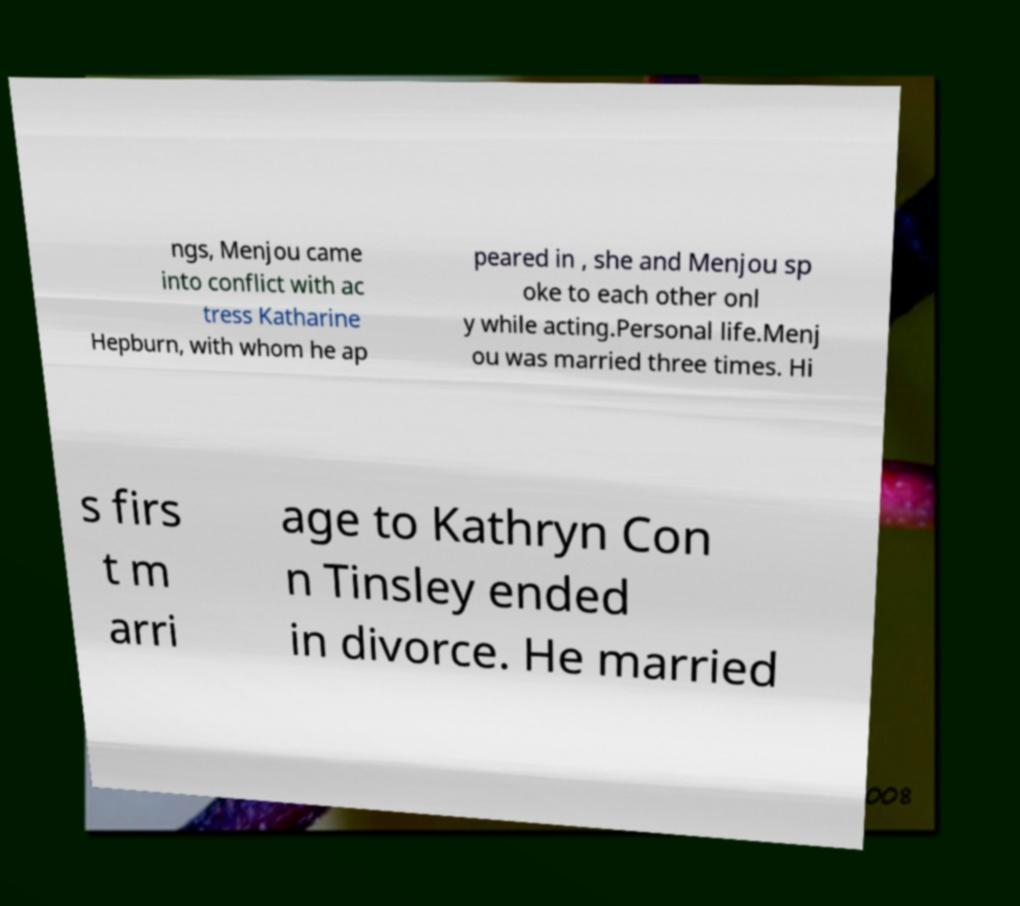I need the written content from this picture converted into text. Can you do that? ngs, Menjou came into conflict with ac tress Katharine Hepburn, with whom he ap peared in , she and Menjou sp oke to each other onl y while acting.Personal life.Menj ou was married three times. Hi s firs t m arri age to Kathryn Con n Tinsley ended in divorce. He married 